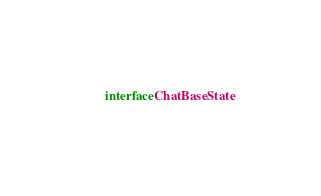Convert code to text. <code><loc_0><loc_0><loc_500><loc_500><_Kotlin_>interface ChatBaseState</code> 